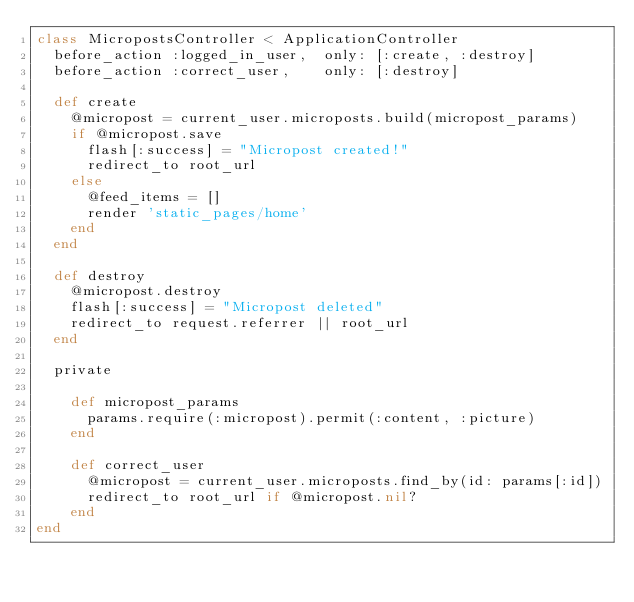<code> <loc_0><loc_0><loc_500><loc_500><_Ruby_>class MicropostsController < ApplicationController
  before_action :logged_in_user,  only: [:create, :destroy]
  before_action :correct_user,    only: [:destroy]

  def create
    @micropost = current_user.microposts.build(micropost_params)
    if @micropost.save
      flash[:success] = "Micropost created!"
      redirect_to root_url
    else
      @feed_items = []
      render 'static_pages/home'
    end
  end

  def destroy
    @micropost.destroy
    flash[:success] = "Micropost deleted"
    redirect_to request.referrer || root_url
  end

  private

    def micropost_params
      params.require(:micropost).permit(:content, :picture)
    end
    
    def correct_user
      @micropost = current_user.microposts.find_by(id: params[:id])
      redirect_to root_url if @micropost.nil?
    end
end
</code> 